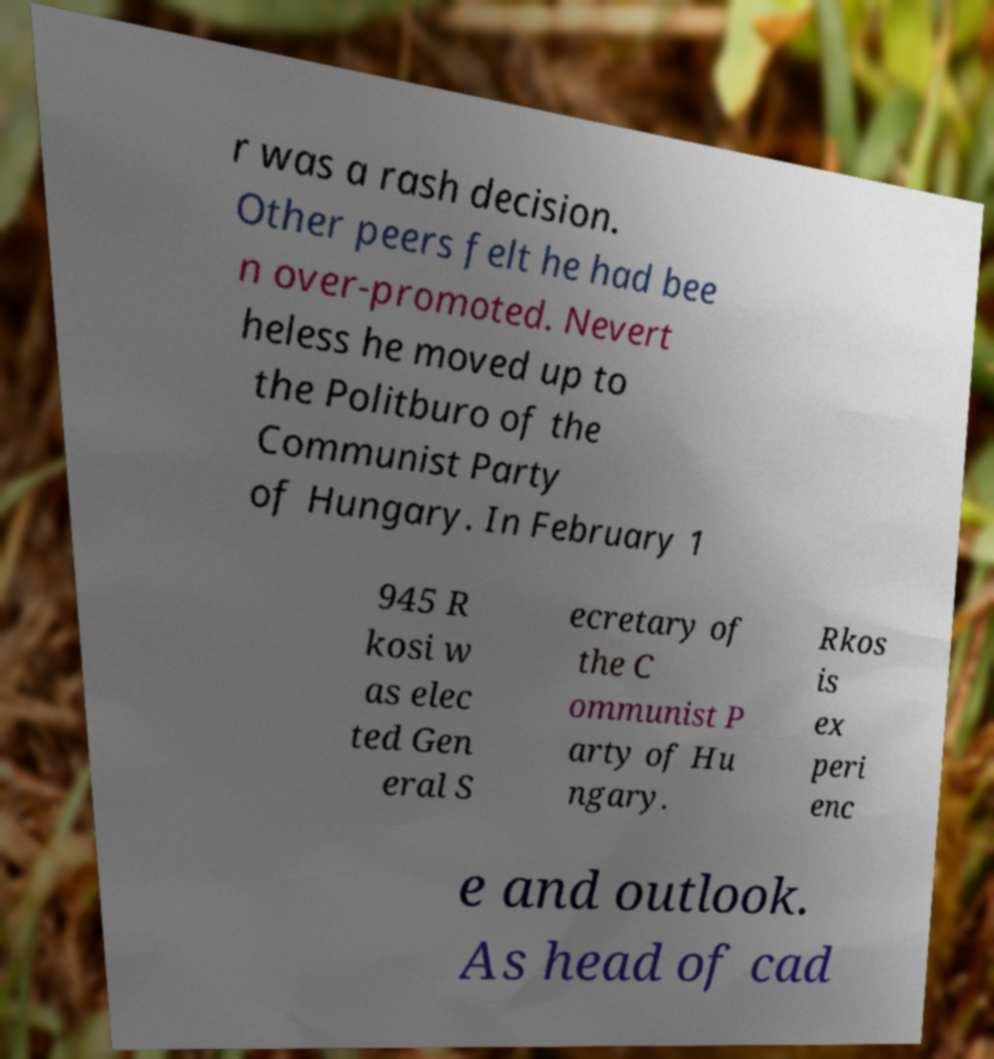Please read and relay the text visible in this image. What does it say? r was a rash decision. Other peers felt he had bee n over-promoted. Nevert heless he moved up to the Politburo of the Communist Party of Hungary. In February 1 945 R kosi w as elec ted Gen eral S ecretary of the C ommunist P arty of Hu ngary. Rkos is ex peri enc e and outlook. As head of cad 